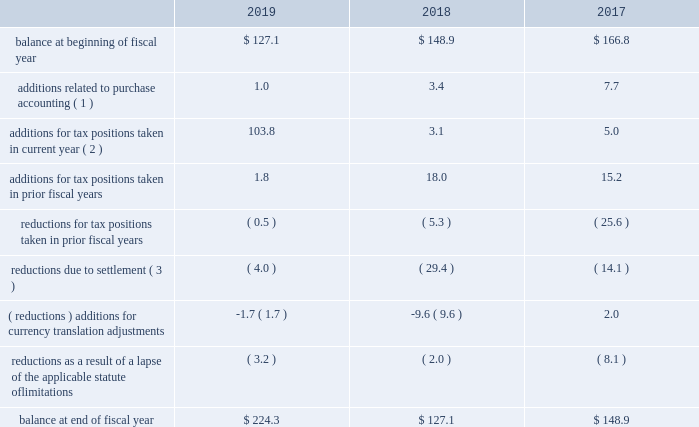Westrock company notes to consolidated financial statements 2014 ( continued ) consistent with prior years , we consider a portion of our earnings from certain foreign subsidiaries as subject to repatriation and we provide for taxes accordingly .
However , we consider the unremitted earnings and all other outside basis differences from all other foreign subsidiaries to be indefinitely reinvested .
Accordingly , we have not provided for any taxes that would be due .
As of september 30 , 2019 , we estimate our outside basis difference in foreign subsidiaries that are considered indefinitely reinvested to be approximately $ 1.6 billion .
The components of the outside basis difference are comprised of purchase accounting adjustments , undistributed earnings , and equity components .
Except for the portion of our earnings from certain foreign subsidiaries where we provided for taxes , we have not provided for any taxes that would be due upon the reversal of the outside basis differences .
However , in the event of a distribution in the form of dividends or dispositions of the subsidiaries , we may be subject to incremental u.s .
Income taxes , subject to an adjustment for foreign tax credits , and withholding taxes or income taxes payable to the foreign jurisdictions .
As of september 30 , 2019 , the determination of the amount of unrecognized deferred tax liability related to any remaining undistributed foreign earnings not subject to the transition tax and additional outside basis differences is not practicable .
A reconciliation of the beginning and ending amount of gross unrecognized tax benefits is as follows ( in millions ) : .
( 1 ) amounts in fiscal 2019 relate to the kapstone acquisition .
Amounts in fiscal 2018 and 2017 relate to the mps acquisition .
( 2 ) additions for tax positions taken in current fiscal year includes primarily positions taken related to foreign subsidiaries .
( 3 ) amounts in fiscal 2019 relate to the settlements of state and foreign audit examinations .
Amounts in fiscal 2018 relate to the settlement of state audit examinations and federal and state amended returns filed related to affirmative adjustments for which there was a reserve .
Amounts in fiscal 2017 relate to the settlement of federal and state audit examinations with taxing authorities .
As of september 30 , 2019 and 2018 , the total amount of unrecognized tax benefits was approximately $ 224.3 million and $ 127.1 million , respectively , exclusive of interest and penalties .
Of these balances , as of september 30 , 2019 and 2018 , if we were to prevail on all unrecognized tax benefits recorded , approximately $ 207.5 million and $ 108.7 million , respectively , would benefit the effective tax rate .
We regularly evaluate , assess and adjust the related liabilities in light of changing facts and circumstances , which could cause the effective tax rate to fluctuate from period to period .
Resolution of the uncertain tax positions could have a material adverse effect on our cash flows or materially benefit our results of operations in future periods depending upon their ultimate resolution .
See 201cnote 18 .
Commitments and contingencies 2014 brazil tax liability 201d we recognize estimated interest and penalties related to unrecognized tax benefits in income tax expense in the consolidated statements of income .
As of september 30 , 2019 , we had liabilities of $ 80.0 million related to estimated interest and penalties for unrecognized tax benefits .
As of september 30 , 2018 , we had liabilities of $ 70.4 million , related to estimated interest and penalties for unrecognized tax benefits .
Our results of operations for the fiscal year ended september 30 , 2019 , 2018 and 2017 include expense of $ 9.7 million , $ 5.8 million and $ 7.4 million , respectively , net of indirect benefits , related to estimated interest and penalties with respect to the liability for unrecognized tax benefits .
As of september 30 , 2019 , it is reasonably possible that our unrecognized tax benefits will decrease by up to $ 8.7 million in the next twelve months due to expiration of various statues of limitations and settlement of issues. .
In 2019 , what percent of the total balance did tax positions taken in the current year amount to? 
Computations: (103.8 / 224.3)
Answer: 0.46277. 